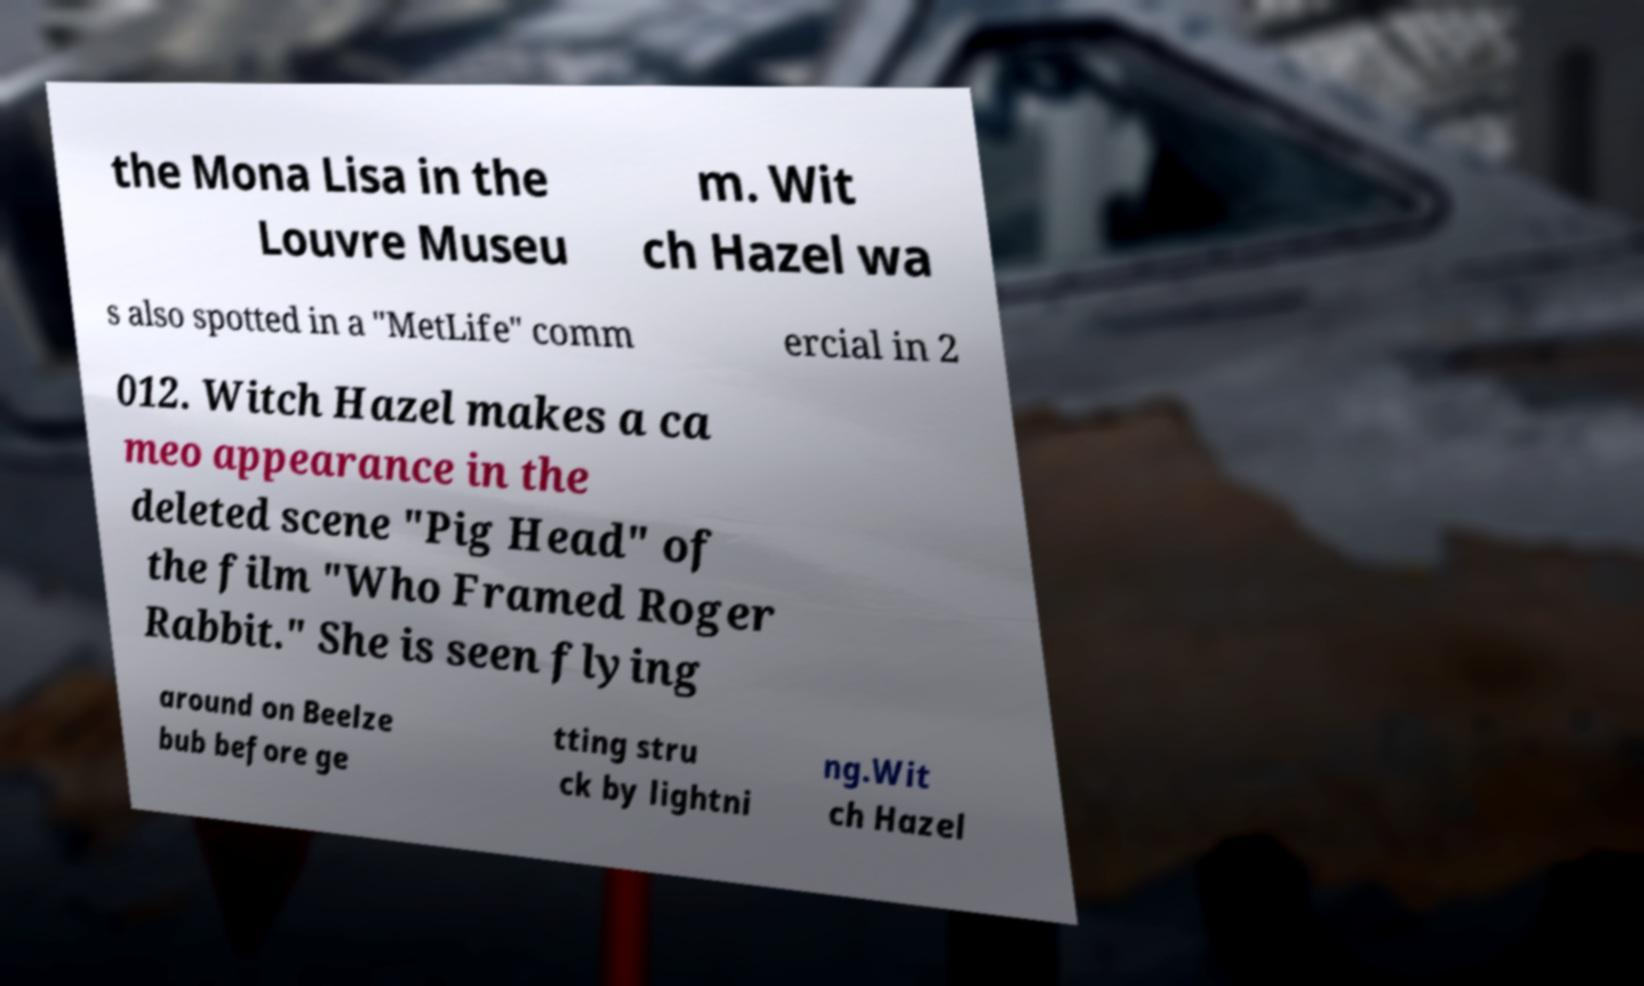Could you assist in decoding the text presented in this image and type it out clearly? the Mona Lisa in the Louvre Museu m. Wit ch Hazel wa s also spotted in a "MetLife" comm ercial in 2 012. Witch Hazel makes a ca meo appearance in the deleted scene "Pig Head" of the film "Who Framed Roger Rabbit." She is seen flying around on Beelze bub before ge tting stru ck by lightni ng.Wit ch Hazel 